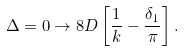<formula> <loc_0><loc_0><loc_500><loc_500>\Delta = 0 \to 8 D \left [ \frac { 1 } { k } - \frac { \delta _ { 1 } } { \pi } \right ] .</formula> 